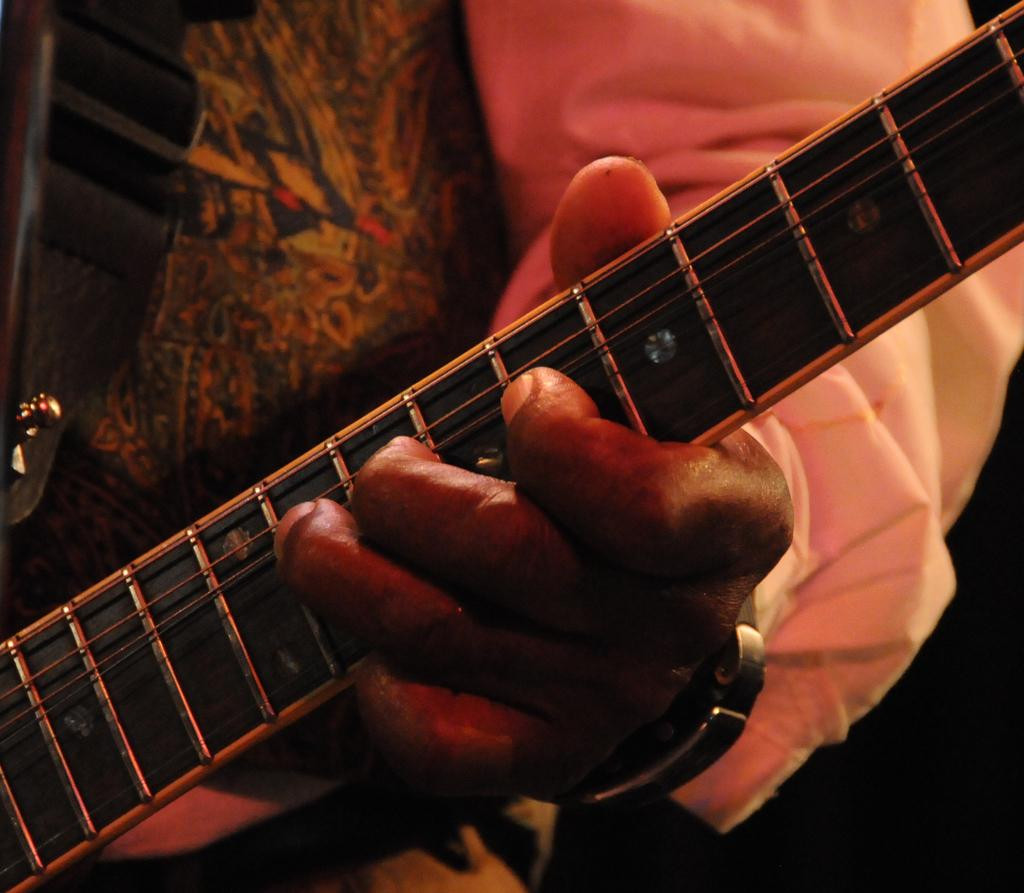What is the main subject of the image? There is a person in the image. What is the person wearing in the image? The person is wearing a white color shirt. What activity is the person engaged in? The person is playing a guitar. What type of glove is the person wearing while playing the guitar in the image? There is no glove visible in the image; the person is not wearing any gloves. How does the person smash the guitar in the image? The person does not smash the guitar in the image; they are playing it. 